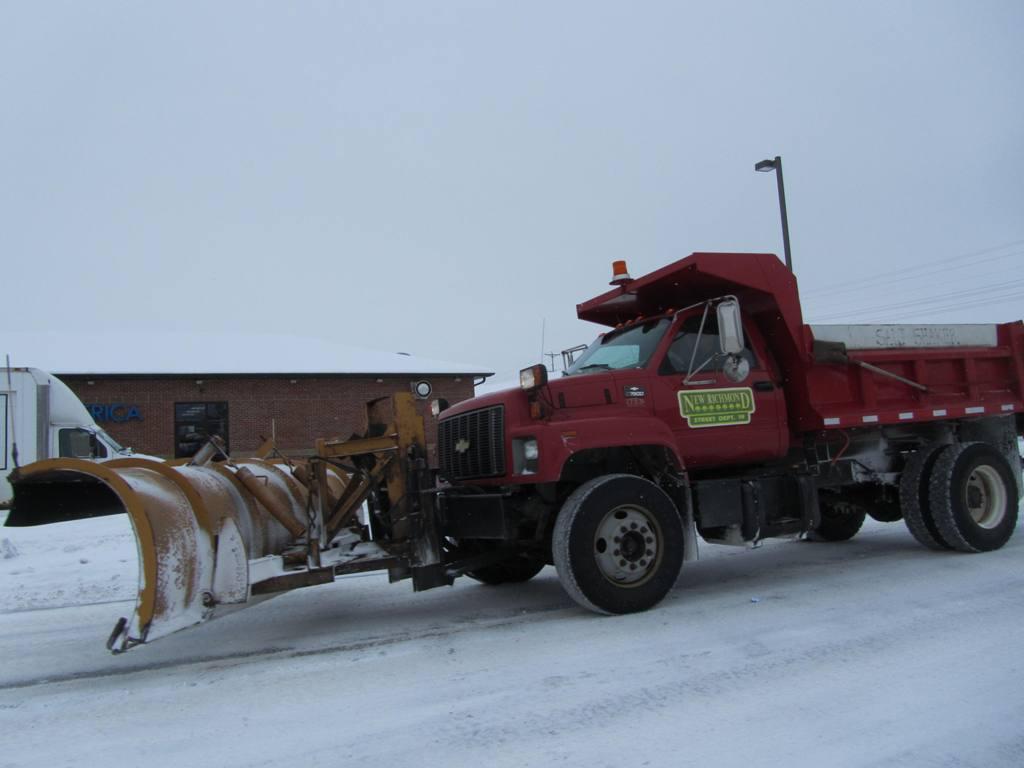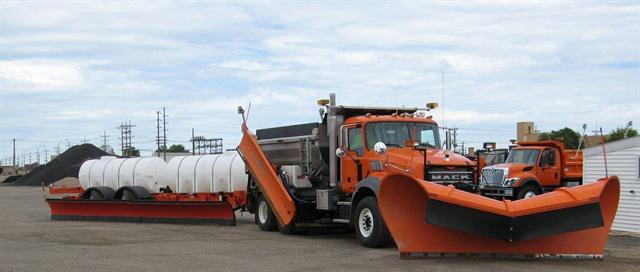The first image is the image on the left, the second image is the image on the right. For the images shown, is this caption "The image on the right contains an orange truck." true? Answer yes or no. Yes. 